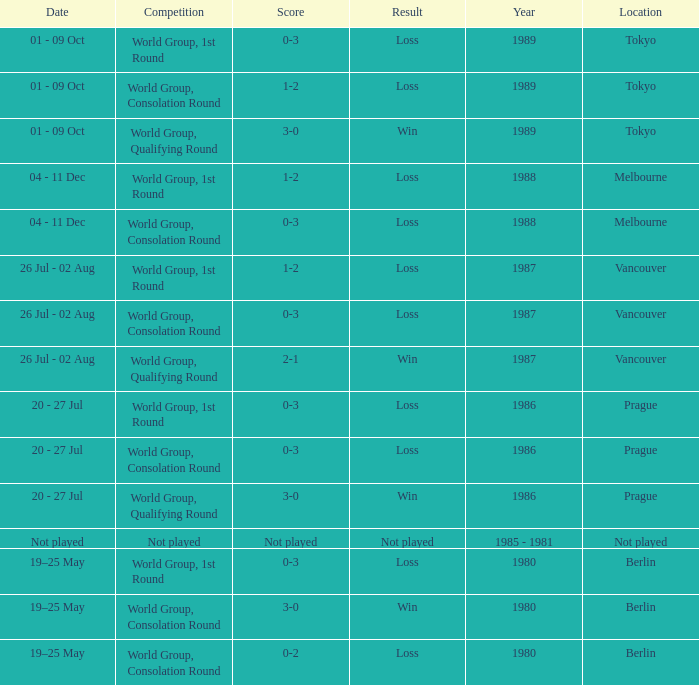What is the year when the date is not played? 1985 - 1981. 